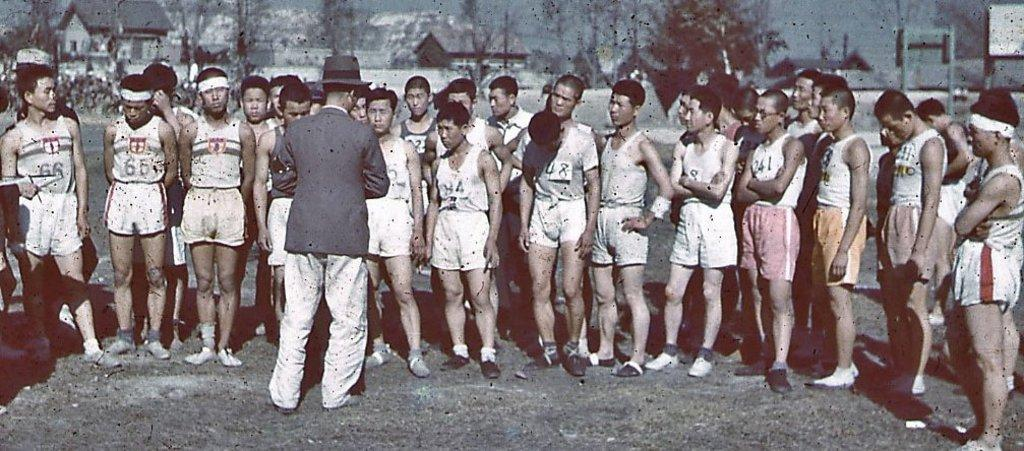What is happening in the center of the image? There are people standing in the center of the image. Can you describe the appearance of one of the individuals? The man on the left is wearing a hat. What can be seen in the background of the image? There are sheds, trees, poles, and the sky visible in the background of the image. What type of thrill can be seen in the image? There is no specific thrill depicted in the image; it simply shows people standing and the surrounding environment. 